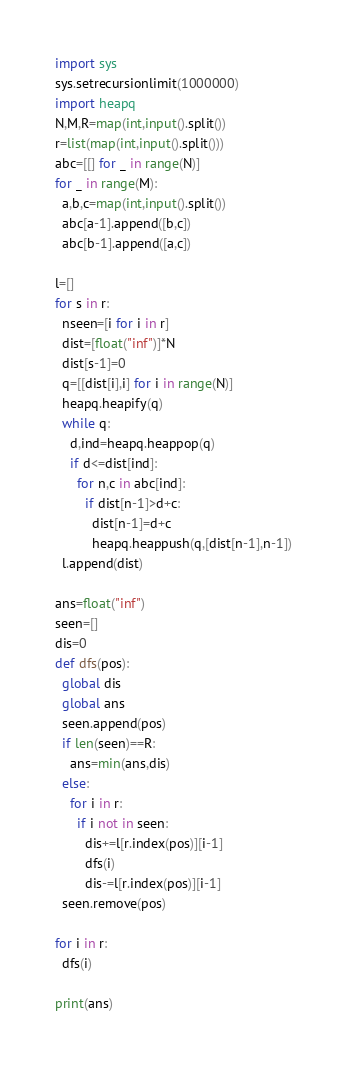<code> <loc_0><loc_0><loc_500><loc_500><_Python_>import sys
sys.setrecursionlimit(1000000)
import heapq
N,M,R=map(int,input().split())
r=list(map(int,input().split()))
abc=[[] for _ in range(N)]
for _ in range(M):
  a,b,c=map(int,input().split())
  abc[a-1].append([b,c])
  abc[b-1].append([a,c])

l=[]
for s in r:
  nseen=[i for i in r]
  dist=[float("inf")]*N
  dist[s-1]=0
  q=[[dist[i],i] for i in range(N)]
  heapq.heapify(q)
  while q:
    d,ind=heapq.heappop(q)
    if d<=dist[ind]:
      for n,c in abc[ind]:
        if dist[n-1]>d+c:
          dist[n-1]=d+c
          heapq.heappush(q,[dist[n-1],n-1])
  l.append(dist)

ans=float("inf")
seen=[]
dis=0
def dfs(pos):
  global dis
  global ans
  seen.append(pos)
  if len(seen)==R:
    ans=min(ans,dis)
  else:
    for i in r:
      if i not in seen:
        dis+=l[r.index(pos)][i-1]
        dfs(i)
        dis-=l[r.index(pos)][i-1]
  seen.remove(pos)

for i in r:
  dfs(i)
  
print(ans)</code> 